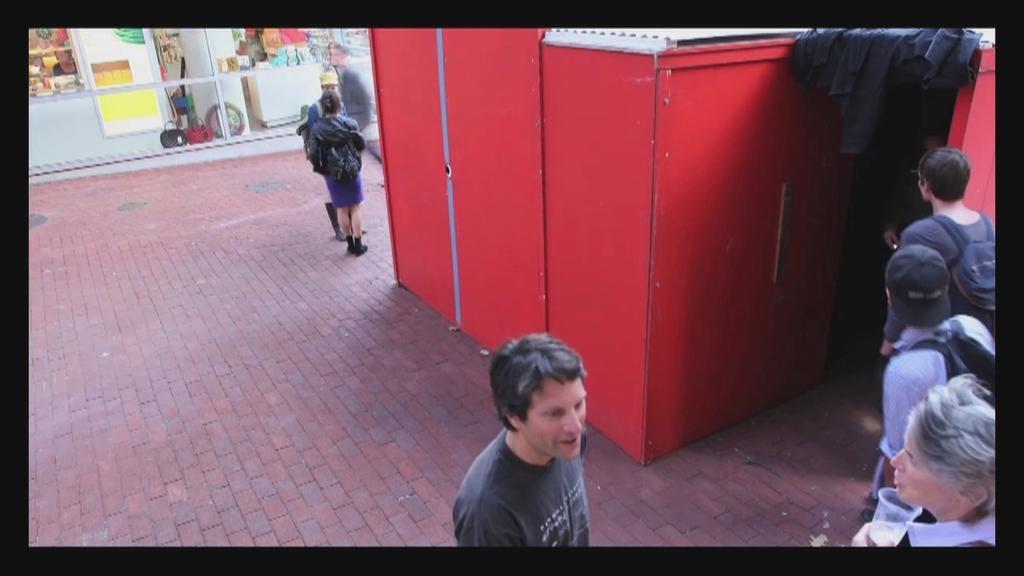Describe this image in one or two sentences. In this picture we can see a few people on the path. We can see a red object. There is a black cloth on the top right. We can see a few bags and other colorful objects in the building. 